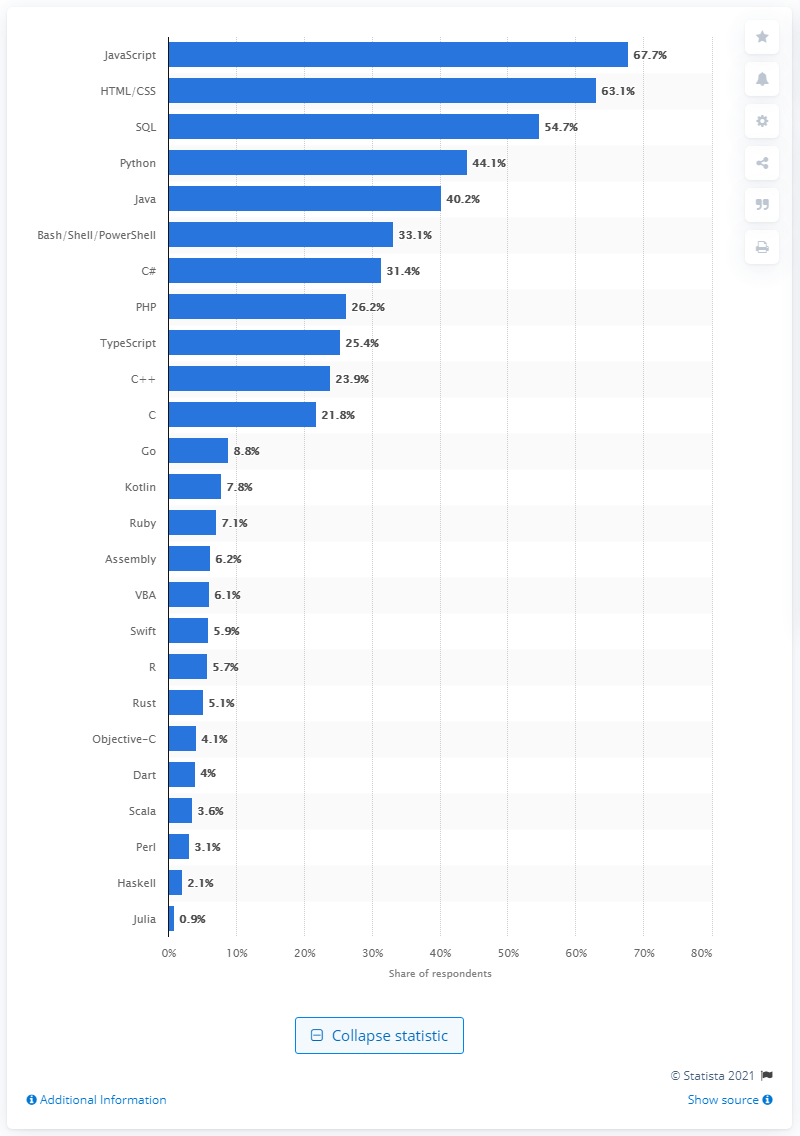Outline some significant characteristics in this image. JavaScript was the programming language most commonly used by software developers. SQL is the programming language that is most widely used. 